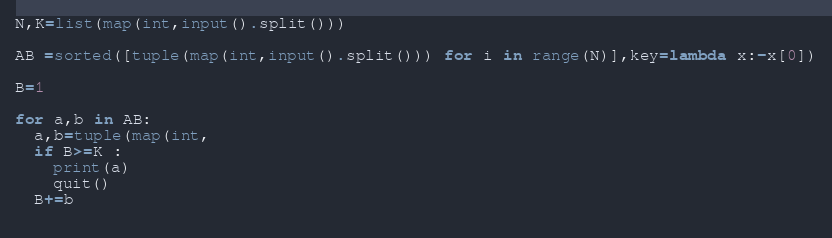<code> <loc_0><loc_0><loc_500><loc_500><_Python_>N,K=list(map(int,input().split()))

AB =sorted([tuple(map(int,input().split())) for i in range(N)],key=lambda x:-x[0])

B=1

for a,b in AB:
  a,b=tuple(map(int,
  if B>=K :
    print(a)
    quit()
  B+=b
  
</code> 